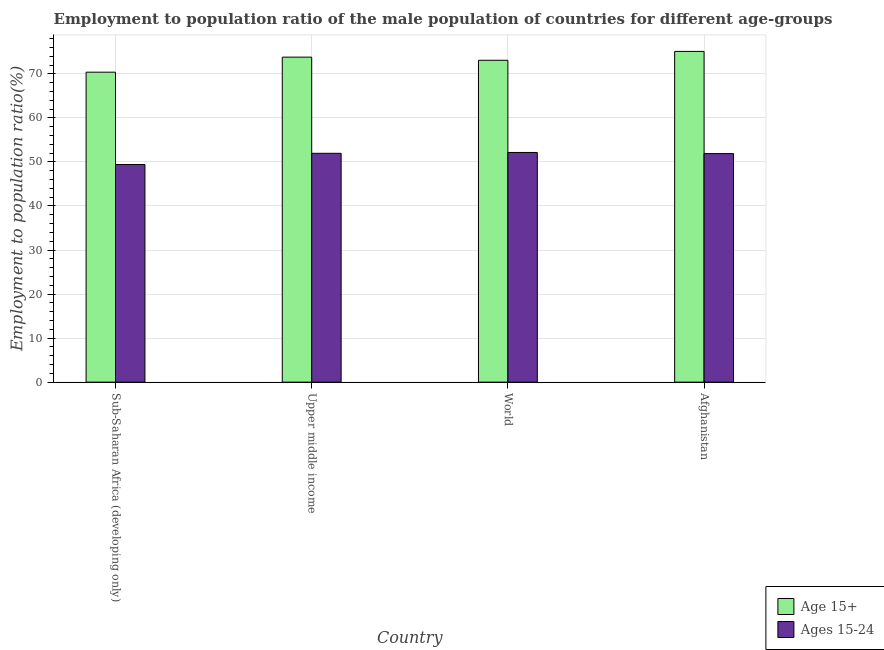How many different coloured bars are there?
Your answer should be very brief. 2. How many groups of bars are there?
Offer a very short reply. 4. Are the number of bars per tick equal to the number of legend labels?
Make the answer very short. Yes. Are the number of bars on each tick of the X-axis equal?
Ensure brevity in your answer.  Yes. How many bars are there on the 4th tick from the left?
Make the answer very short. 2. How many bars are there on the 2nd tick from the right?
Provide a short and direct response. 2. What is the label of the 4th group of bars from the left?
Ensure brevity in your answer.  Afghanistan. In how many cases, is the number of bars for a given country not equal to the number of legend labels?
Provide a short and direct response. 0. What is the employment to population ratio(age 15-24) in Sub-Saharan Africa (developing only)?
Make the answer very short. 49.41. Across all countries, what is the maximum employment to population ratio(age 15+)?
Offer a terse response. 75.1. Across all countries, what is the minimum employment to population ratio(age 15-24)?
Ensure brevity in your answer.  49.41. In which country was the employment to population ratio(age 15+) maximum?
Your answer should be compact. Afghanistan. In which country was the employment to population ratio(age 15-24) minimum?
Give a very brief answer. Sub-Saharan Africa (developing only). What is the total employment to population ratio(age 15+) in the graph?
Your answer should be very brief. 292.37. What is the difference between the employment to population ratio(age 15-24) in Sub-Saharan Africa (developing only) and that in Upper middle income?
Make the answer very short. -2.55. What is the difference between the employment to population ratio(age 15+) in Afghanistan and the employment to population ratio(age 15-24) in Upper middle income?
Ensure brevity in your answer.  23.14. What is the average employment to population ratio(age 15-24) per country?
Provide a short and direct response. 51.36. What is the difference between the employment to population ratio(age 15+) and employment to population ratio(age 15-24) in Sub-Saharan Africa (developing only)?
Provide a succinct answer. 20.97. In how many countries, is the employment to population ratio(age 15+) greater than 38 %?
Your response must be concise. 4. What is the ratio of the employment to population ratio(age 15+) in Upper middle income to that in World?
Offer a terse response. 1.01. Is the employment to population ratio(age 15+) in Upper middle income less than that in World?
Ensure brevity in your answer.  No. What is the difference between the highest and the second highest employment to population ratio(age 15+)?
Make the answer very short. 1.3. What is the difference between the highest and the lowest employment to population ratio(age 15-24)?
Your response must be concise. 2.74. In how many countries, is the employment to population ratio(age 15+) greater than the average employment to population ratio(age 15+) taken over all countries?
Keep it short and to the point. 2. Is the sum of the employment to population ratio(age 15+) in Upper middle income and World greater than the maximum employment to population ratio(age 15-24) across all countries?
Offer a very short reply. Yes. What does the 1st bar from the left in World represents?
Make the answer very short. Age 15+. What does the 1st bar from the right in Afghanistan represents?
Your answer should be very brief. Ages 15-24. Are the values on the major ticks of Y-axis written in scientific E-notation?
Give a very brief answer. No. Does the graph contain any zero values?
Provide a succinct answer. No. Does the graph contain grids?
Your response must be concise. Yes. Where does the legend appear in the graph?
Ensure brevity in your answer.  Bottom right. How are the legend labels stacked?
Make the answer very short. Vertical. What is the title of the graph?
Your answer should be compact. Employment to population ratio of the male population of countries for different age-groups. What is the label or title of the X-axis?
Keep it short and to the point. Country. What is the label or title of the Y-axis?
Give a very brief answer. Employment to population ratio(%). What is the Employment to population ratio(%) in Age 15+ in Sub-Saharan Africa (developing only)?
Your answer should be very brief. 70.38. What is the Employment to population ratio(%) in Ages 15-24 in Sub-Saharan Africa (developing only)?
Your response must be concise. 49.41. What is the Employment to population ratio(%) of Age 15+ in Upper middle income?
Ensure brevity in your answer.  73.8. What is the Employment to population ratio(%) in Ages 15-24 in Upper middle income?
Keep it short and to the point. 51.96. What is the Employment to population ratio(%) of Age 15+ in World?
Keep it short and to the point. 73.09. What is the Employment to population ratio(%) of Ages 15-24 in World?
Provide a short and direct response. 52.15. What is the Employment to population ratio(%) of Age 15+ in Afghanistan?
Provide a succinct answer. 75.1. What is the Employment to population ratio(%) in Ages 15-24 in Afghanistan?
Provide a short and direct response. 51.9. Across all countries, what is the maximum Employment to population ratio(%) of Age 15+?
Provide a succinct answer. 75.1. Across all countries, what is the maximum Employment to population ratio(%) in Ages 15-24?
Offer a very short reply. 52.15. Across all countries, what is the minimum Employment to population ratio(%) of Age 15+?
Give a very brief answer. 70.38. Across all countries, what is the minimum Employment to population ratio(%) in Ages 15-24?
Give a very brief answer. 49.41. What is the total Employment to population ratio(%) of Age 15+ in the graph?
Offer a very short reply. 292.37. What is the total Employment to population ratio(%) of Ages 15-24 in the graph?
Keep it short and to the point. 205.43. What is the difference between the Employment to population ratio(%) of Age 15+ in Sub-Saharan Africa (developing only) and that in Upper middle income?
Your answer should be compact. -3.42. What is the difference between the Employment to population ratio(%) in Ages 15-24 in Sub-Saharan Africa (developing only) and that in Upper middle income?
Offer a terse response. -2.55. What is the difference between the Employment to population ratio(%) in Age 15+ in Sub-Saharan Africa (developing only) and that in World?
Your answer should be compact. -2.7. What is the difference between the Employment to population ratio(%) of Ages 15-24 in Sub-Saharan Africa (developing only) and that in World?
Ensure brevity in your answer.  -2.74. What is the difference between the Employment to population ratio(%) in Age 15+ in Sub-Saharan Africa (developing only) and that in Afghanistan?
Your answer should be compact. -4.72. What is the difference between the Employment to population ratio(%) of Ages 15-24 in Sub-Saharan Africa (developing only) and that in Afghanistan?
Ensure brevity in your answer.  -2.49. What is the difference between the Employment to population ratio(%) of Age 15+ in Upper middle income and that in World?
Offer a terse response. 0.71. What is the difference between the Employment to population ratio(%) of Ages 15-24 in Upper middle income and that in World?
Your answer should be very brief. -0.19. What is the difference between the Employment to population ratio(%) in Age 15+ in Upper middle income and that in Afghanistan?
Offer a very short reply. -1.3. What is the difference between the Employment to population ratio(%) of Ages 15-24 in Upper middle income and that in Afghanistan?
Provide a short and direct response. 0.06. What is the difference between the Employment to population ratio(%) in Age 15+ in World and that in Afghanistan?
Your answer should be compact. -2.01. What is the difference between the Employment to population ratio(%) in Ages 15-24 in World and that in Afghanistan?
Give a very brief answer. 0.25. What is the difference between the Employment to population ratio(%) in Age 15+ in Sub-Saharan Africa (developing only) and the Employment to population ratio(%) in Ages 15-24 in Upper middle income?
Your answer should be very brief. 18.42. What is the difference between the Employment to population ratio(%) in Age 15+ in Sub-Saharan Africa (developing only) and the Employment to population ratio(%) in Ages 15-24 in World?
Your answer should be compact. 18.23. What is the difference between the Employment to population ratio(%) of Age 15+ in Sub-Saharan Africa (developing only) and the Employment to population ratio(%) of Ages 15-24 in Afghanistan?
Your answer should be very brief. 18.48. What is the difference between the Employment to population ratio(%) in Age 15+ in Upper middle income and the Employment to population ratio(%) in Ages 15-24 in World?
Provide a succinct answer. 21.65. What is the difference between the Employment to population ratio(%) of Age 15+ in Upper middle income and the Employment to population ratio(%) of Ages 15-24 in Afghanistan?
Your answer should be very brief. 21.9. What is the difference between the Employment to population ratio(%) of Age 15+ in World and the Employment to population ratio(%) of Ages 15-24 in Afghanistan?
Ensure brevity in your answer.  21.19. What is the average Employment to population ratio(%) in Age 15+ per country?
Ensure brevity in your answer.  73.09. What is the average Employment to population ratio(%) of Ages 15-24 per country?
Your answer should be very brief. 51.36. What is the difference between the Employment to population ratio(%) in Age 15+ and Employment to population ratio(%) in Ages 15-24 in Sub-Saharan Africa (developing only)?
Give a very brief answer. 20.97. What is the difference between the Employment to population ratio(%) of Age 15+ and Employment to population ratio(%) of Ages 15-24 in Upper middle income?
Your answer should be compact. 21.84. What is the difference between the Employment to population ratio(%) in Age 15+ and Employment to population ratio(%) in Ages 15-24 in World?
Give a very brief answer. 20.93. What is the difference between the Employment to population ratio(%) of Age 15+ and Employment to population ratio(%) of Ages 15-24 in Afghanistan?
Your response must be concise. 23.2. What is the ratio of the Employment to population ratio(%) in Age 15+ in Sub-Saharan Africa (developing only) to that in Upper middle income?
Your answer should be very brief. 0.95. What is the ratio of the Employment to population ratio(%) in Ages 15-24 in Sub-Saharan Africa (developing only) to that in Upper middle income?
Offer a terse response. 0.95. What is the ratio of the Employment to population ratio(%) of Age 15+ in Sub-Saharan Africa (developing only) to that in Afghanistan?
Provide a short and direct response. 0.94. What is the ratio of the Employment to population ratio(%) of Ages 15-24 in Sub-Saharan Africa (developing only) to that in Afghanistan?
Your answer should be very brief. 0.95. What is the ratio of the Employment to population ratio(%) in Age 15+ in Upper middle income to that in World?
Your response must be concise. 1.01. What is the ratio of the Employment to population ratio(%) in Ages 15-24 in Upper middle income to that in World?
Keep it short and to the point. 1. What is the ratio of the Employment to population ratio(%) in Age 15+ in Upper middle income to that in Afghanistan?
Make the answer very short. 0.98. What is the ratio of the Employment to population ratio(%) of Ages 15-24 in Upper middle income to that in Afghanistan?
Offer a terse response. 1. What is the ratio of the Employment to population ratio(%) of Age 15+ in World to that in Afghanistan?
Provide a short and direct response. 0.97. What is the difference between the highest and the second highest Employment to population ratio(%) of Age 15+?
Give a very brief answer. 1.3. What is the difference between the highest and the second highest Employment to population ratio(%) in Ages 15-24?
Your answer should be very brief. 0.19. What is the difference between the highest and the lowest Employment to population ratio(%) of Age 15+?
Make the answer very short. 4.72. What is the difference between the highest and the lowest Employment to population ratio(%) in Ages 15-24?
Offer a very short reply. 2.74. 